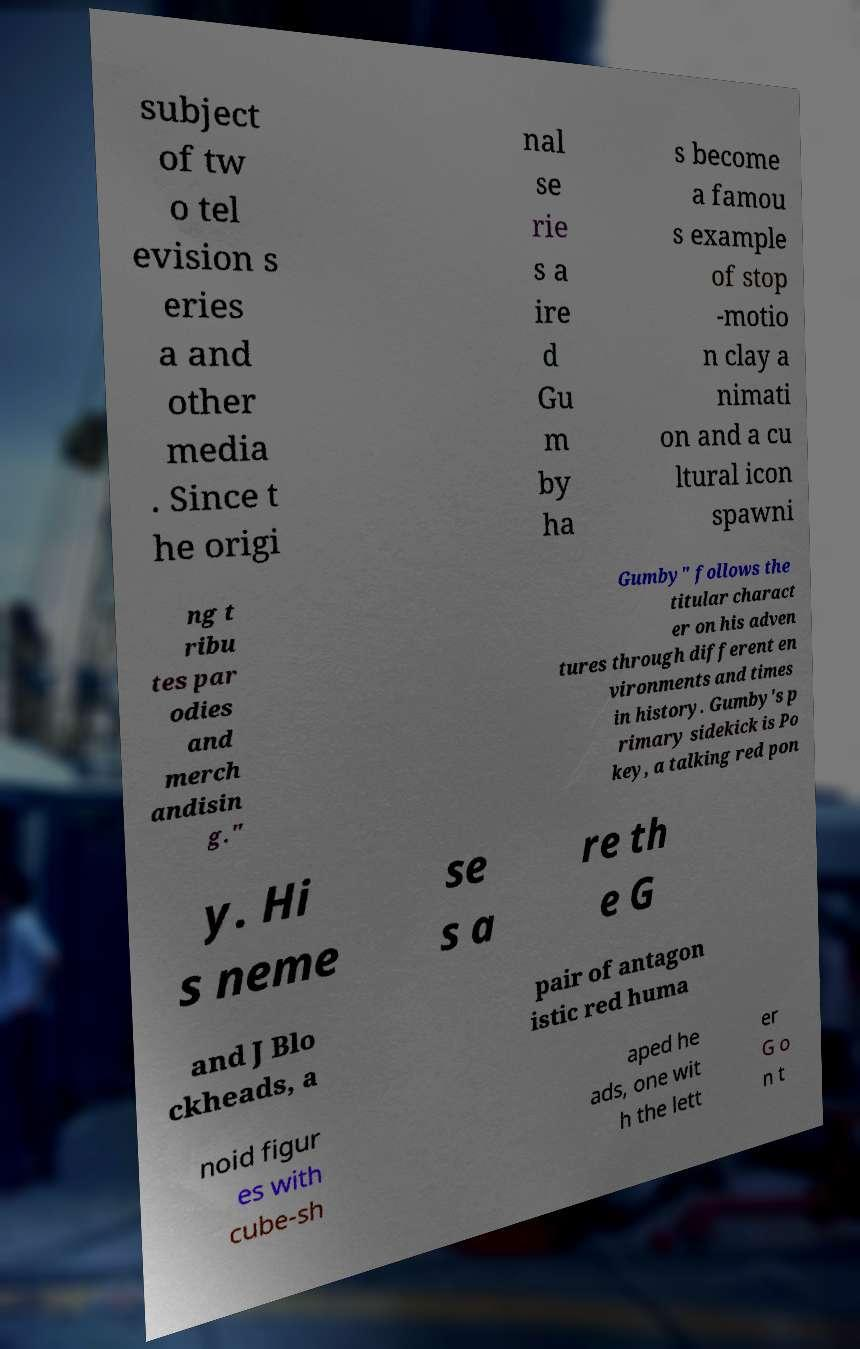Can you accurately transcribe the text from the provided image for me? subject of tw o tel evision s eries a and other media . Since t he origi nal se rie s a ire d Gu m by ha s become a famou s example of stop -motio n clay a nimati on and a cu ltural icon spawni ng t ribu tes par odies and merch andisin g." Gumby" follows the titular charact er on his adven tures through different en vironments and times in history. Gumby's p rimary sidekick is Po key, a talking red pon y. Hi s neme se s a re th e G and J Blo ckheads, a pair of antagon istic red huma noid figur es with cube-sh aped he ads, one wit h the lett er G o n t 